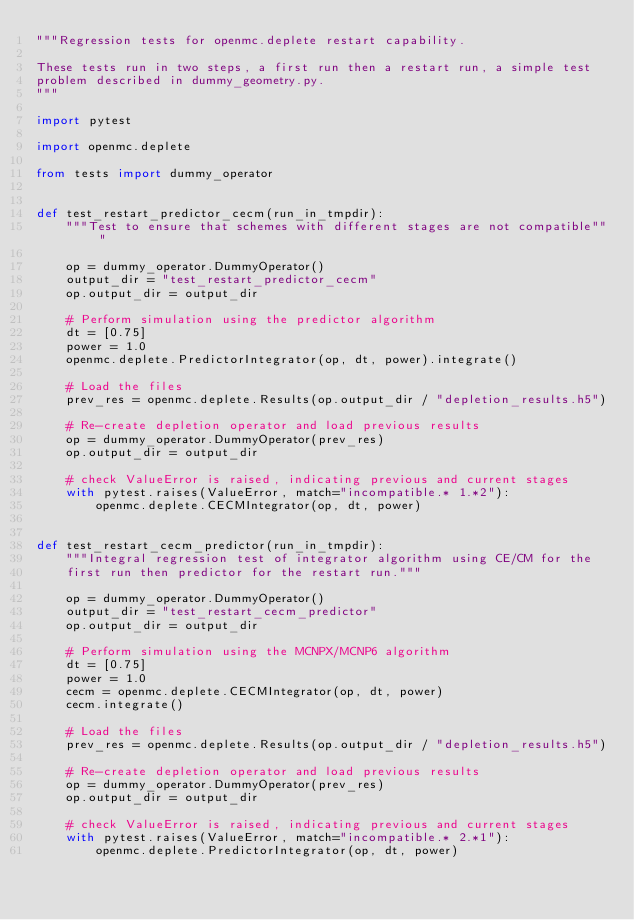Convert code to text. <code><loc_0><loc_0><loc_500><loc_500><_Python_>"""Regression tests for openmc.deplete restart capability.

These tests run in two steps, a first run then a restart run, a simple test
problem described in dummy_geometry.py.
"""

import pytest

import openmc.deplete

from tests import dummy_operator


def test_restart_predictor_cecm(run_in_tmpdir):
    """Test to ensure that schemes with different stages are not compatible"""

    op = dummy_operator.DummyOperator()
    output_dir = "test_restart_predictor_cecm"
    op.output_dir = output_dir

    # Perform simulation using the predictor algorithm
    dt = [0.75]
    power = 1.0
    openmc.deplete.PredictorIntegrator(op, dt, power).integrate()

    # Load the files
    prev_res = openmc.deplete.Results(op.output_dir / "depletion_results.h5")

    # Re-create depletion operator and load previous results
    op = dummy_operator.DummyOperator(prev_res)
    op.output_dir = output_dir

    # check ValueError is raised, indicating previous and current stages
    with pytest.raises(ValueError, match="incompatible.* 1.*2"):
        openmc.deplete.CECMIntegrator(op, dt, power)


def test_restart_cecm_predictor(run_in_tmpdir):
    """Integral regression test of integrator algorithm using CE/CM for the
    first run then predictor for the restart run."""

    op = dummy_operator.DummyOperator()
    output_dir = "test_restart_cecm_predictor"
    op.output_dir = output_dir

    # Perform simulation using the MCNPX/MCNP6 algorithm
    dt = [0.75]
    power = 1.0
    cecm = openmc.deplete.CECMIntegrator(op, dt, power)
    cecm.integrate()

    # Load the files
    prev_res = openmc.deplete.Results(op.output_dir / "depletion_results.h5")

    # Re-create depletion operator and load previous results
    op = dummy_operator.DummyOperator(prev_res)
    op.output_dir = output_dir

    # check ValueError is raised, indicating previous and current stages
    with pytest.raises(ValueError, match="incompatible.* 2.*1"):
        openmc.deplete.PredictorIntegrator(op, dt, power)

</code> 